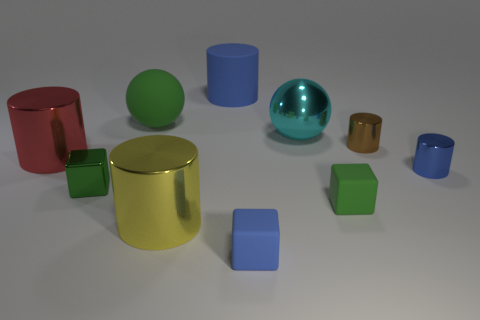The blue rubber thing that is in front of the big matte ball has what shape?
Provide a short and direct response. Cube. How many green things are either large spheres or big metal balls?
Provide a succinct answer. 1. Is the material of the small brown cylinder the same as the tiny blue cylinder?
Make the answer very short. Yes. How many brown metal objects are in front of the small brown shiny cylinder?
Your answer should be very brief. 0. There is a cylinder that is both in front of the brown cylinder and to the right of the yellow cylinder; what is it made of?
Your answer should be compact. Metal. What number of cubes are tiny gray metal things or tiny matte objects?
Your answer should be compact. 2. What material is the tiny brown object that is the same shape as the red metallic thing?
Your response must be concise. Metal. The cyan ball that is the same material as the brown cylinder is what size?
Your answer should be very brief. Large. Is the shape of the rubber object to the left of the yellow cylinder the same as the big shiny object right of the yellow shiny thing?
Provide a succinct answer. Yes. The large thing that is the same material as the green ball is what color?
Ensure brevity in your answer.  Blue. 